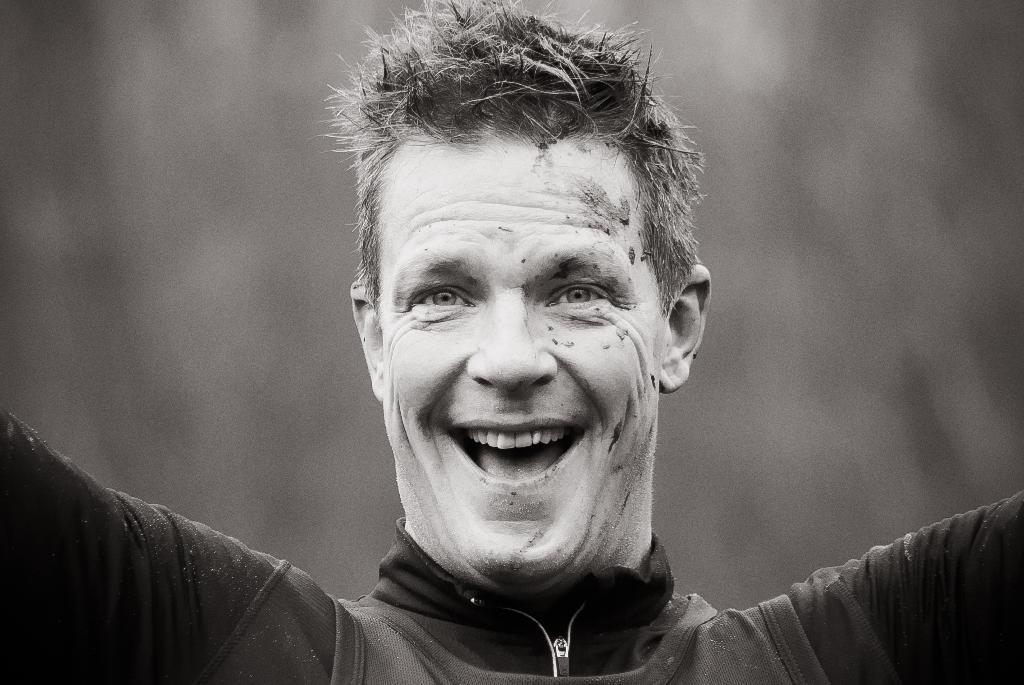Who is the main subject in the image? There is a man in the image. Where is the man located in the image? The man is in the middle of the image. What is the man wearing in the image? The man is wearing a black color jacket. What expression does the man have on his face? There is a smile on the man's face. How many patches can be seen on the man's jacket in the image? There are no patches visible on the man's jacket in the image. What type of clothing would be appropriate for the man to wear during the summer season? The provided facts do not mention the season or any specific clothing, so it is not possible to determine what type of clothing would be appropriate for the man to wear during the summer season. 